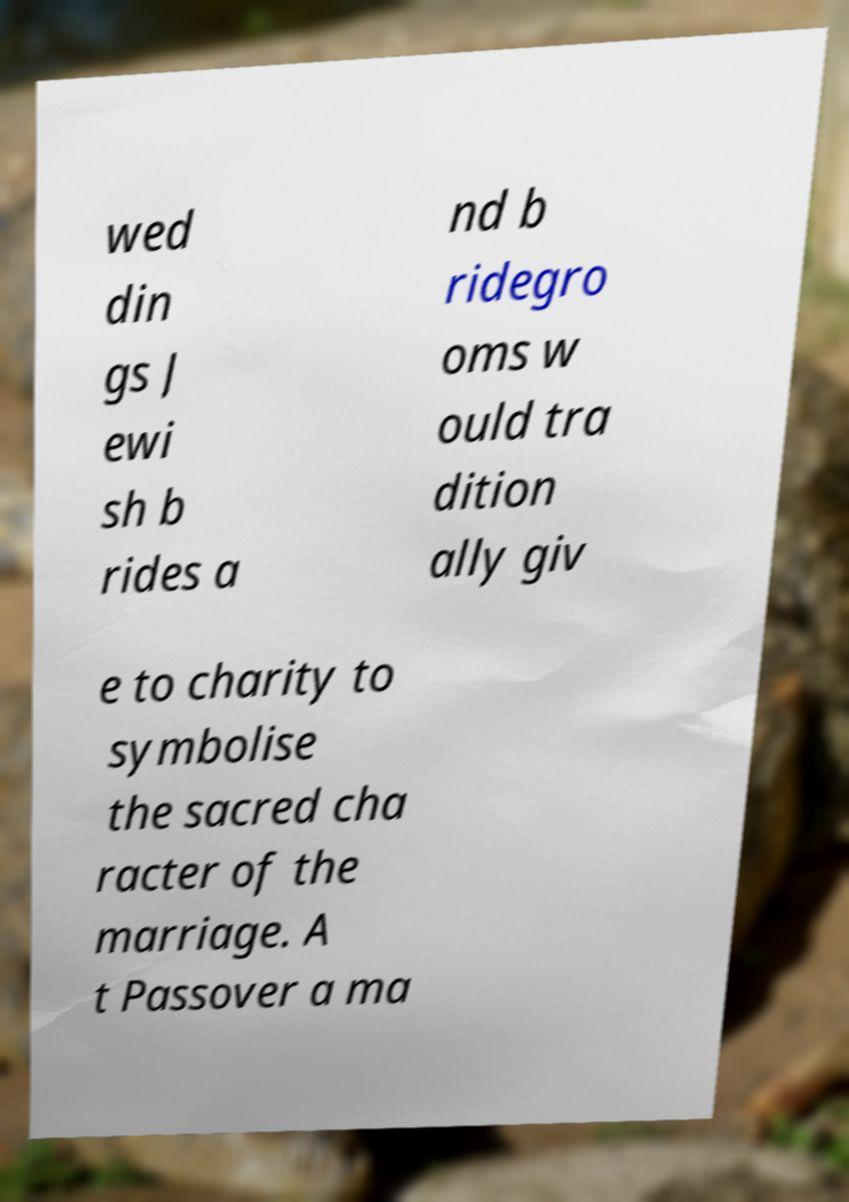Can you read and provide the text displayed in the image?This photo seems to have some interesting text. Can you extract and type it out for me? wed din gs J ewi sh b rides a nd b ridegro oms w ould tra dition ally giv e to charity to symbolise the sacred cha racter of the marriage. A t Passover a ma 